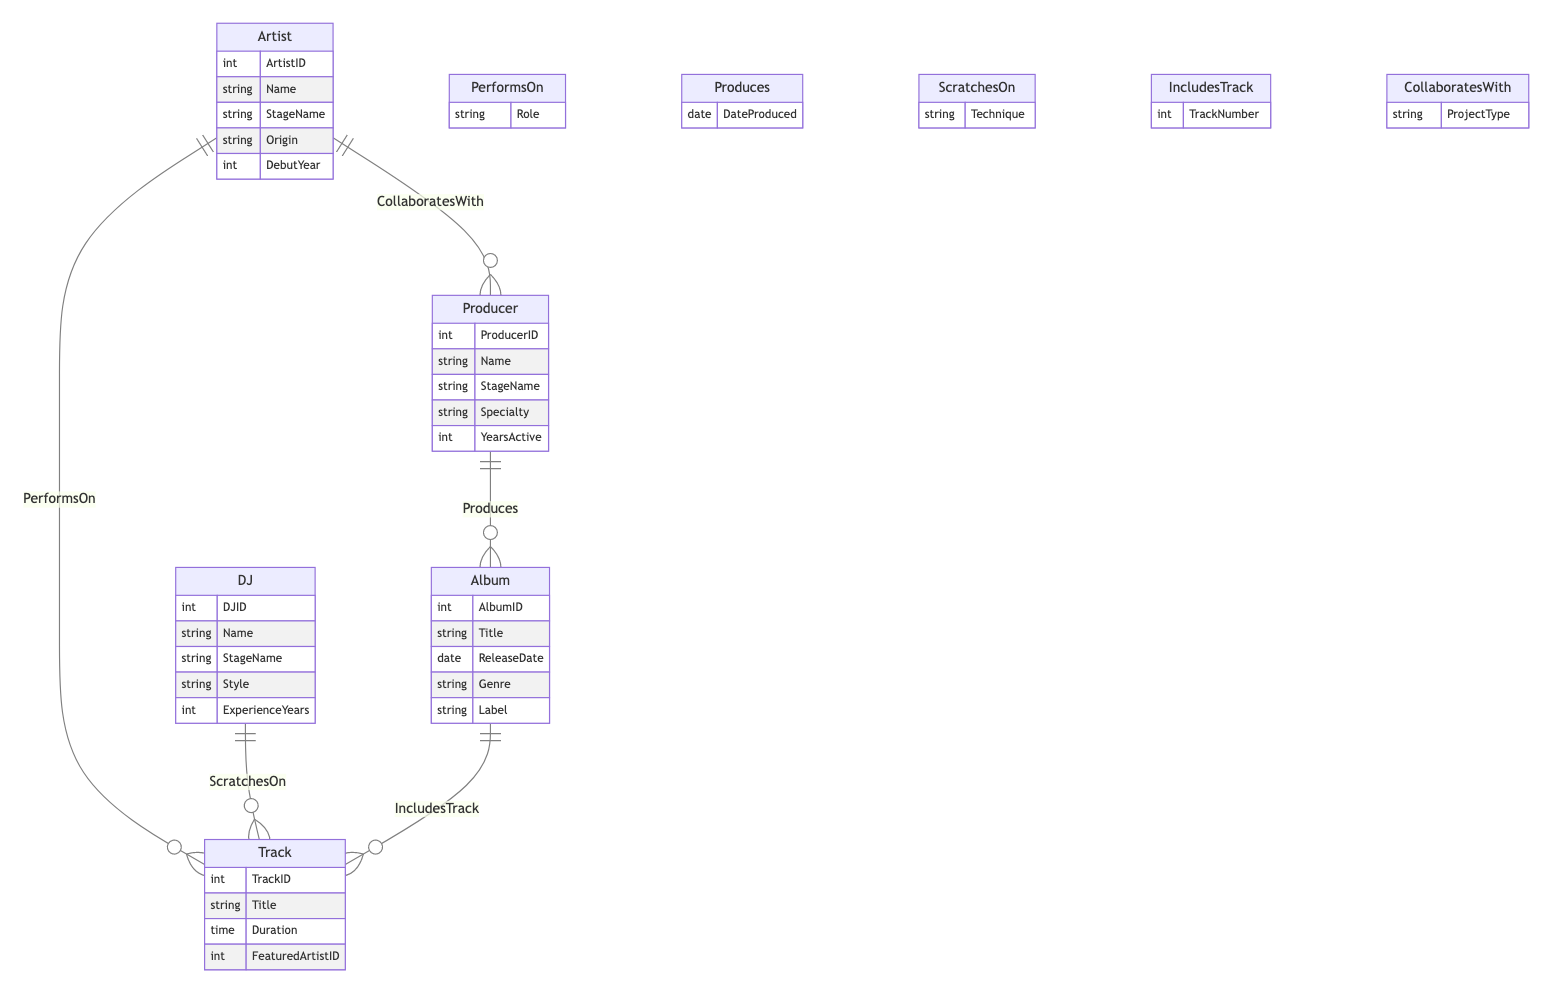What's the main relationship between Artist and Track? The diagram shows that the main relationship between Artist and Track is represented by "PerformsOn", indicating that artists contribute their vocals or performance to tracks.
Answer: PerformsOn How many attributes does the Album entity have? The Album entity is listed with five attributes: AlbumID, Title, ReleaseDate, Genre, and Label, which are outlined in the diagram.
Answer: Five What is the role of the Producer in the relationship with Album? The diagram reveals that the Producer's role in relation to the Album is described by the "Produces" relationship, indicating that producers are the ones responsible for creating or producing albums.
Answer: Produces Which entity is directly related to the DJ? In the diagram, the DJ is directly related to the Track through the relationship "ScratchesOn", indicating a collaborative role where DJs use scratching techniques on tracks.
Answer: Track What is the relationship type between Artist and Producer? The relationship type between Artist and Producer is defined as "CollaboratesWith", illustrating that artists and producers work together on various projects.
Answer: CollaboratesWith How many types of entities are represented in the diagram? The diagram contains five types of entities: Artist, DJ, Producer, Album, and Track, as indicated in the entity section.
Answer: Five What is the attribute associated with the relationship "IncludesTrack"? The relationship "IncludesTrack" has an associated attribute of "TrackNumber", which provides information about the order of tracks on an album.
Answer: TrackNumber Which relationship indicates a featured artist? The "PerformsOn" relationship indicates a featured artist, as it connects artists to specific tracks while including various roles they may have on those tracks.
Answer: PerformsOn How is the DJ's experience represented in the diagram? The DJ's experience is represented by the attribute "ExperienceYears", which quantifies the number of years they have been active in the DJ scene.
Answer: ExperienceYears 